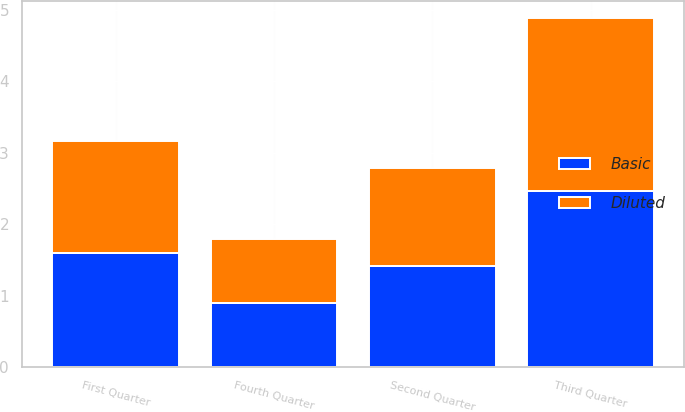<chart> <loc_0><loc_0><loc_500><loc_500><stacked_bar_chart><ecel><fcel>First Quarter<fcel>Second Quarter<fcel>Third Quarter<fcel>Fourth Quarter<nl><fcel>Basic<fcel>1.6<fcel>1.42<fcel>2.47<fcel>0.9<nl><fcel>Diluted<fcel>1.56<fcel>1.37<fcel>2.41<fcel>0.89<nl></chart> 